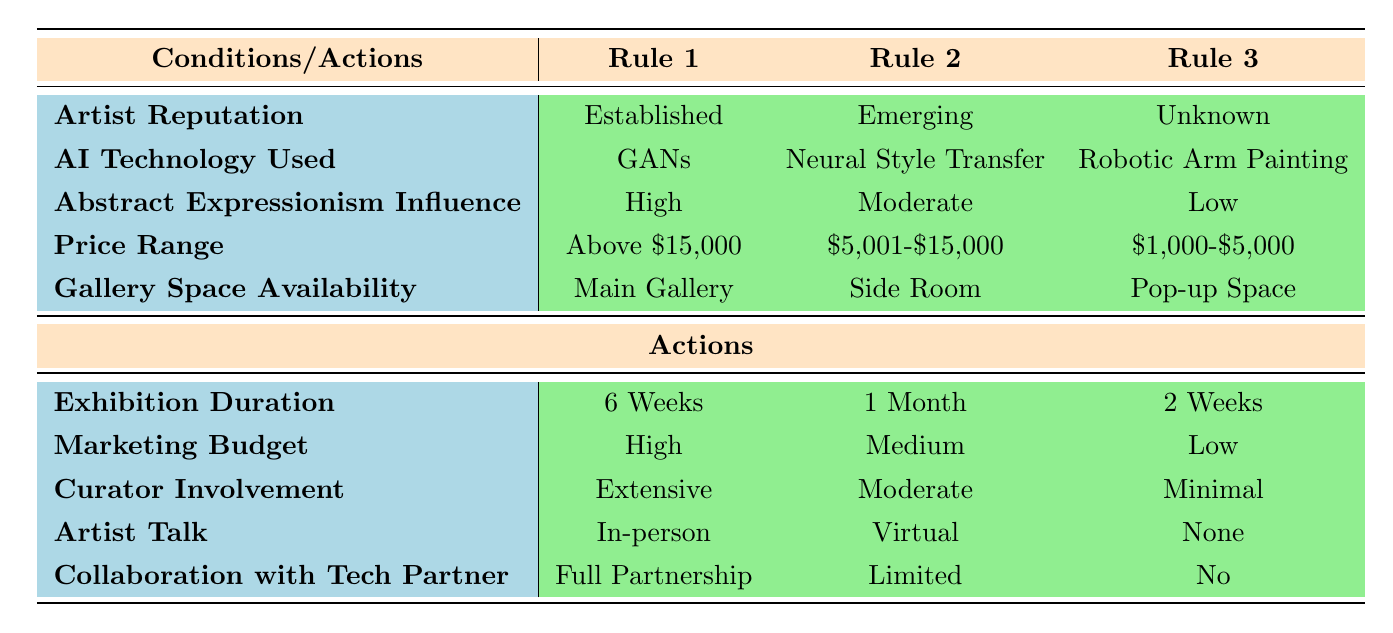What is the exhibition duration for an established artist using GANs with high Abstract Expressionism influence? From the table, under Rule 1 for the established artist using GANs with high Abstract Expressionism influence, the exhibition duration is listed as 6 weeks.
Answer: 6 Weeks Which AI technology is used for the exhibition with a price range of $1,000-$5,000? Referring to Rule 3, for the price range of $1,000-$5,000, the AI technology used is Robotic Arm Painting.
Answer: Robotic Arm Painting Is the marketing budget for an emerging artist using Neural Style Transfer moderate? According to Rule 2, the marketing budget for an emerging artist using Neural Style Transfer is indeed labeled as Medium, so the statement is true.
Answer: Yes What is the curator involvement for an unknown artist using Robotic Arm Painting with low Abstract Expressionism influence? Looking at Rule 3, the curator involvement indicated for an unknown artist using Robotic Arm Painting with low Abstract Expressionism influence is Minimal.
Answer: Minimal How many exhibition duration options are listed in the table? There are three options for exhibition duration: 6 Weeks, 1 Month, and 2 Weeks. Thus, the total count is three.
Answer: 3 What is the price range for the exhibition with high marketing budget and extensive curator involvement? Analyzing Rule 1, which lists a high marketing budget and extensive curator involvement, the price range set for that exhibition is above $15,000.
Answer: Above $15,000 For an exhibition in a pop-up space, what is the collaboration level with the tech partner? In Rule 3, the collaboration with the tech partner for an exhibition held in a pop-up space is listed as No.
Answer: No What is the exhibition duration and marketing budget for an emerging artist with a price range of $5,001-$15,000? From Rule 2, the exhibition duration for the emerging artist in that price range is 1 Month, and the marketing budget is Medium.
Answer: 1 Month, Medium Which exhibition rules involve in-person artist talks? The only rule that involves an in-person artist talk is Rule 1 for the established artist using GANs with high Abstract Expressionism influence.
Answer: Rule 1 